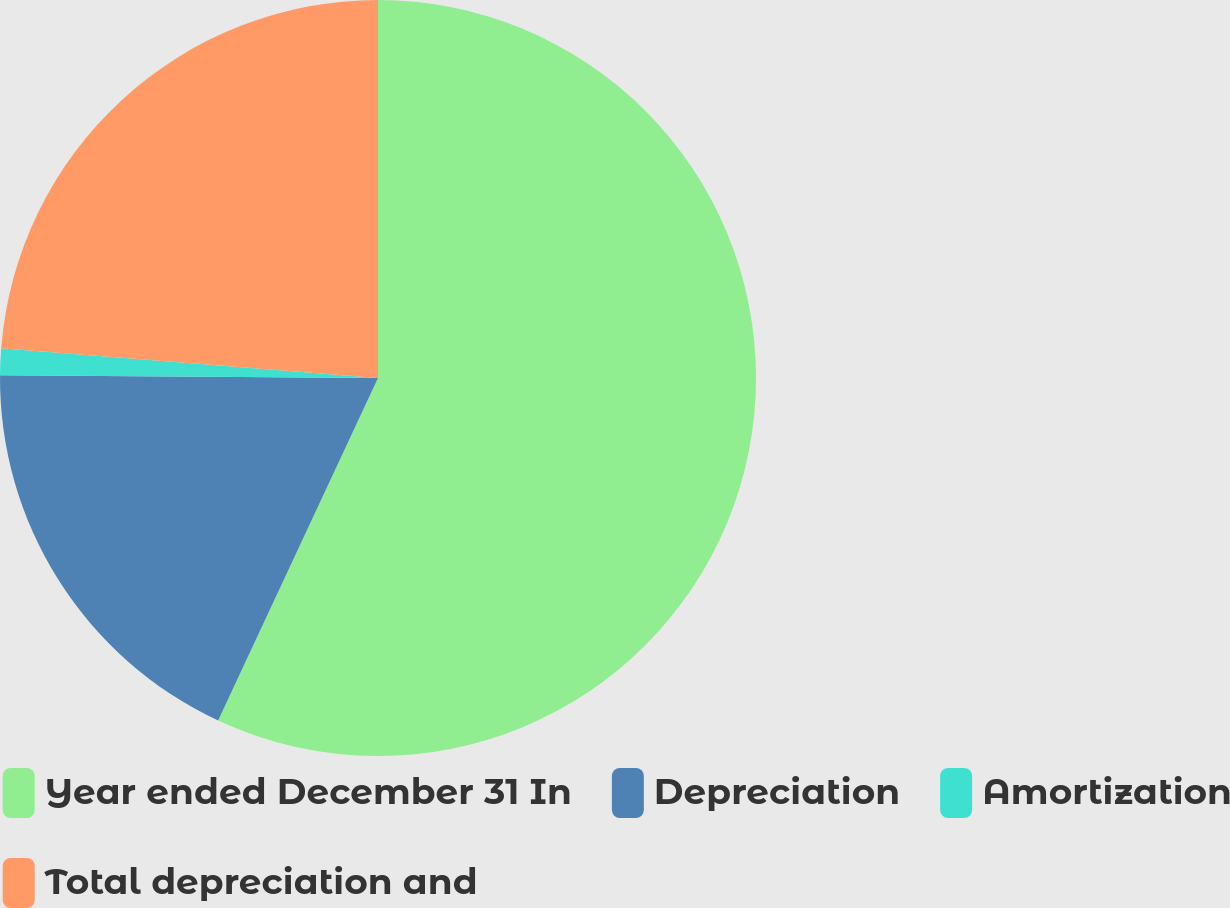Convert chart to OTSL. <chart><loc_0><loc_0><loc_500><loc_500><pie_chart><fcel>Year ended December 31 In<fcel>Depreciation<fcel>Amortization<fcel>Total depreciation and<nl><fcel>56.95%<fcel>18.17%<fcel>1.13%<fcel>23.75%<nl></chart> 